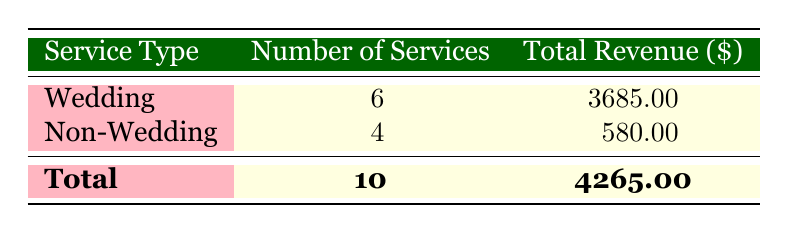What is the total revenue generated from wedding floral services? According to the table, the total revenue for wedding services is 3685.00
Answer: 3685.00 What is the total revenue generated from non-wedding floral services? The table indicates that non-wedding services generated a total revenue of 580.00
Answer: 580.00 How many total services were provided in the wedding category? The table shows that there were 6 services under the wedding category
Answer: 6 How many services were provided in the non-wedding category? From the table, we can see that there were 4 services in the non-wedding category
Answer: 4 What is the total number of floral services provided? The total number of services is the sum of both wedding and non-wedding services: 6 (wedding) + 4 (non-wedding) = 10
Answer: 10 Is the total revenue from wedding services greater than that from non-wedding services? Yes, the wedding services generated 3685.00, which is greater than the non-wedding services revenue of 580.00
Answer: Yes What is the revenue difference between wedding and non-wedding floral services? To find the difference, subtract the non-wedding revenue from the wedding revenue: 3685.00 - 580.00 = 3105.00
Answer: 3105.00 What average revenue per service was generated from wedding floral services? To find this, divide the total revenue from weddings (3685.00) by the number of wedding services (6): 3685.00 / 6 = approximately 614.17
Answer: 614.17 If the revenue from the four non-wedding arrangements was doubled, what would the new total revenue of non-wedding services be? Doubling the current revenue of 580.00 gives us 580.00 * 2 = 1160.00, which would be the new total revenue for non-wedding services
Answer: 1160.00 Is there more than one arrangement type listed under non-wedding services? No, the table only lists three non-wedding arrangements: Get Well Soon, Corporate Event, and Birthday
Answer: No 